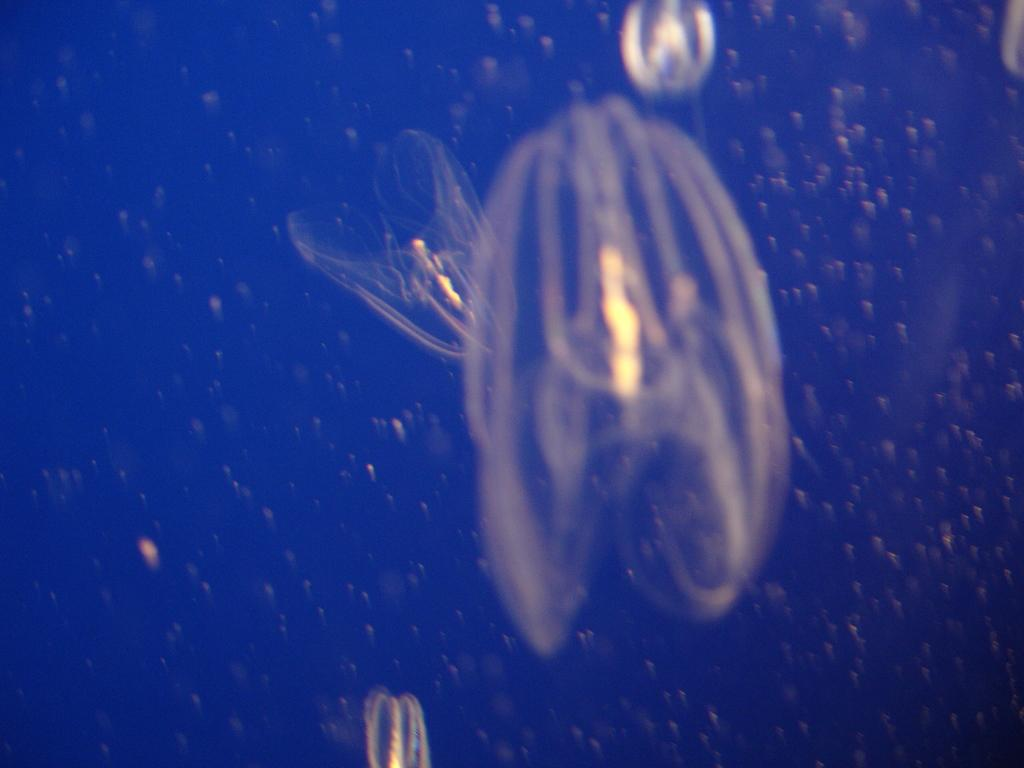What type of sea creatures are in the image? There are jelly fishes in the image. What are the jelly fishes doing in the image? The jelly fishes are moving in the water. What type of produce can be seen growing in the image? There is no produce present in the image; it features jelly fishes moving in the water. 